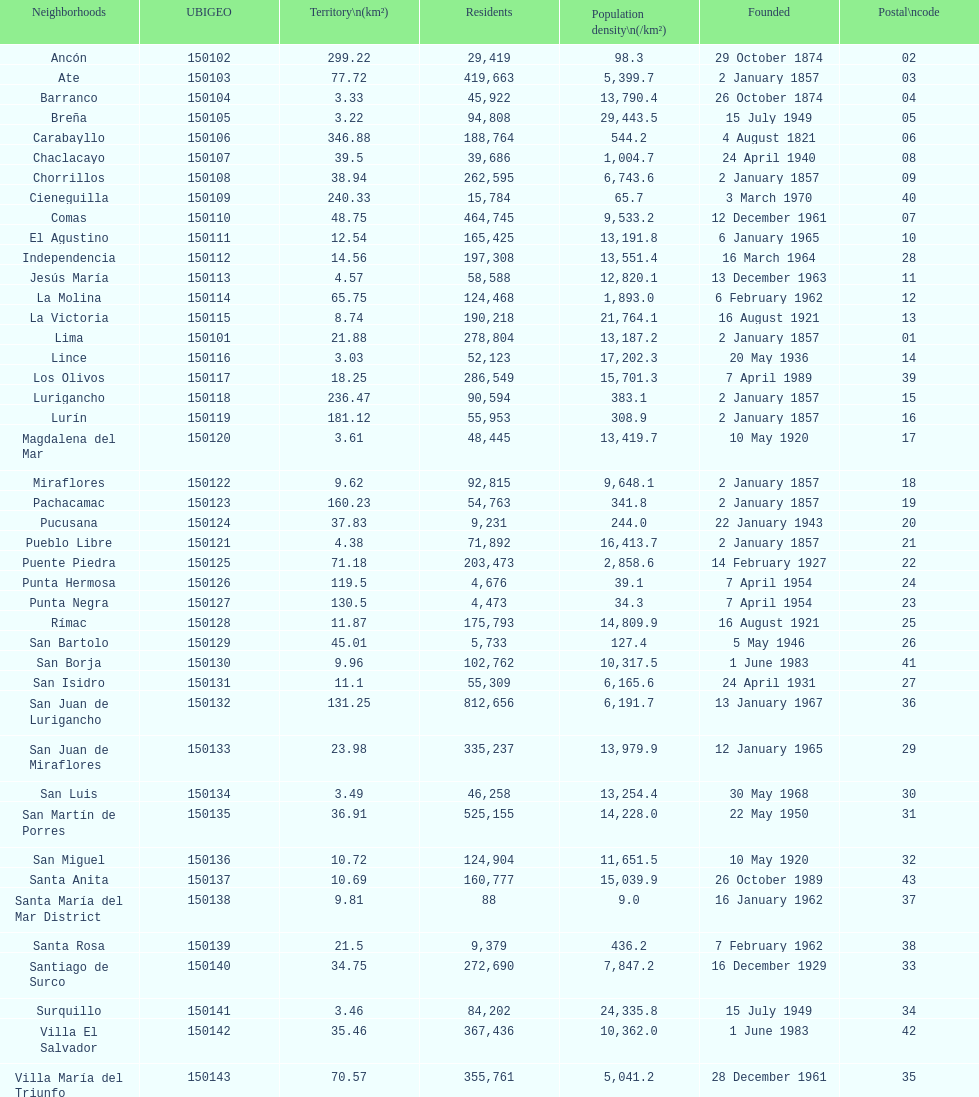How many districts are there in this city? 43. 